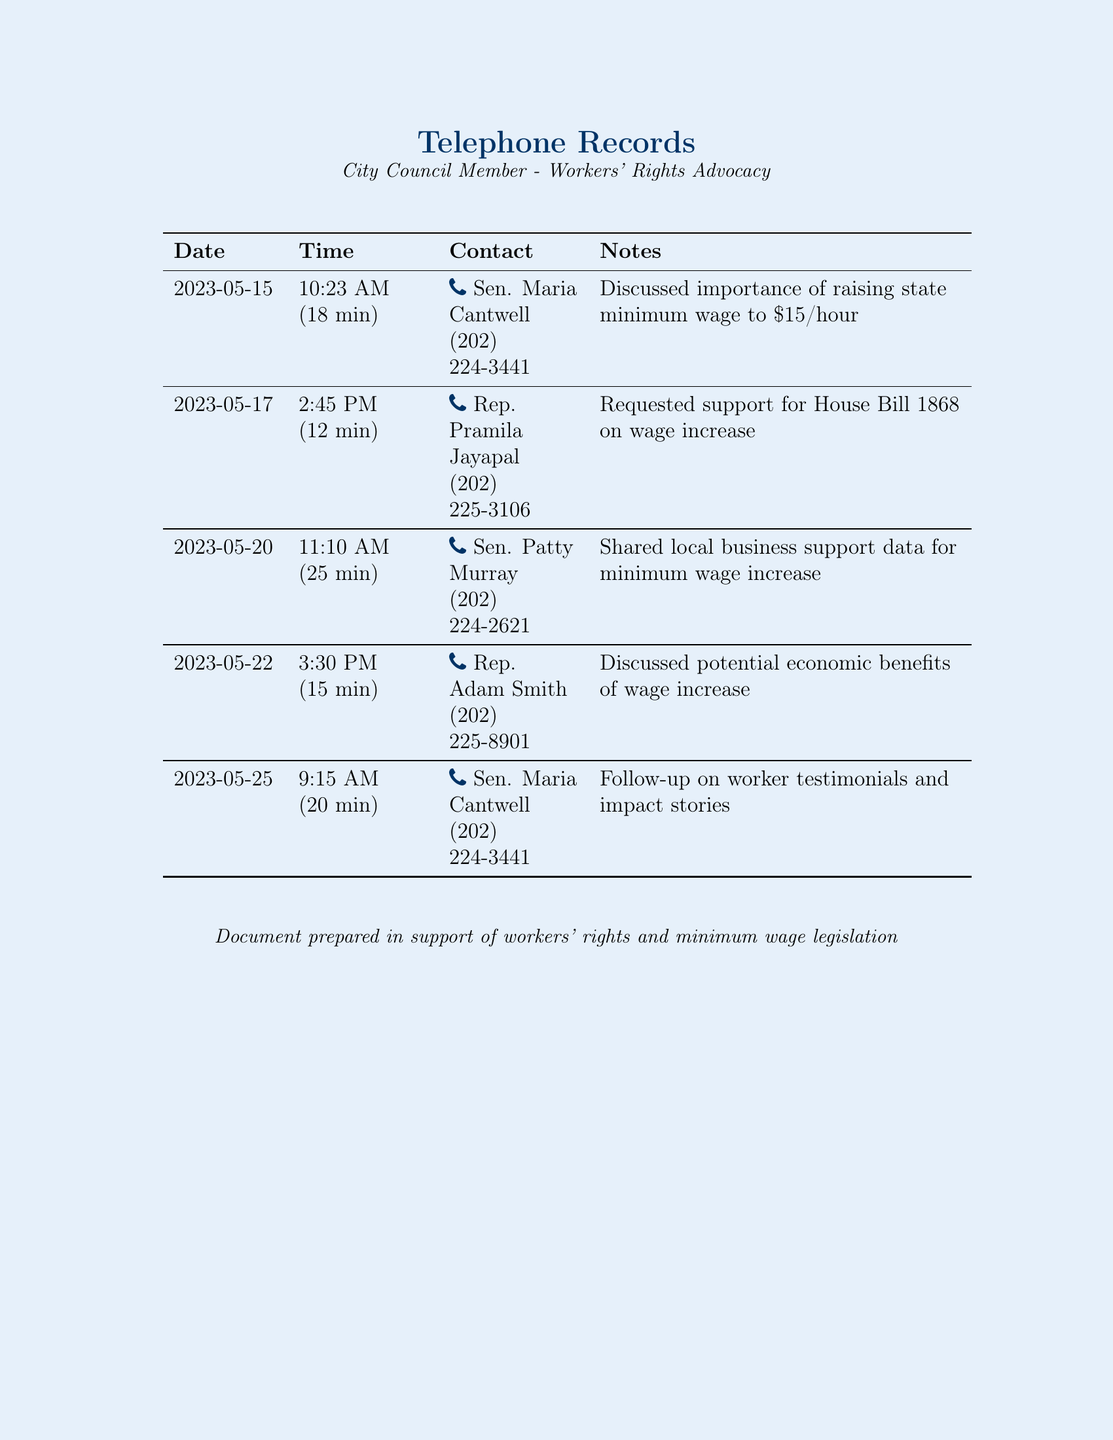what is the date of the first call? The first call was made on May 15, 2023, which is the date listed in the record.
Answer: May 15, 2023 who did the council member speak to on May 20? The record shows that on May 20, the council member spoke to Sen. Patty Murray.
Answer: Sen. Patty Murray how long was the longest phone call? The longest phone call listed in the document is 25 minutes.
Answer: 25 min what is the main topic discussed in the calls? The calls primarily discuss the increase of state minimum wage to $15/hour, as indicated in multiple notes.
Answer: Minimum wage increase which representative was contacted on May 17? On May 17, the council member contacted Rep. Pramila Jayapal.
Answer: Rep. Pramila Jayapal how many times did the council member call Sen. Maria Cantwell? The council member called Sen. Maria Cantwell two times, as noted in the records.
Answer: 2 times what piece of legislation was discussed during the call with Rep. Pramila Jayapal? The legislation discussed was House Bill 1868 regarding wage increase.
Answer: House Bill 1868 what was shared during the May 20 call with Sen. Patty Murray? The council member shared local business support data for the minimum wage increase during the call.
Answer: Local business support data 